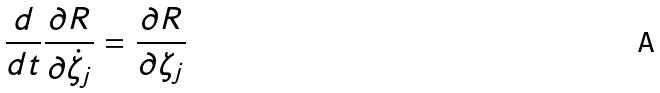<formula> <loc_0><loc_0><loc_500><loc_500>\frac { d } { d t } \frac { \partial R } { \partial \dot { \zeta } _ { j } } = \frac { \partial R } { \partial \zeta _ { j } }</formula> 